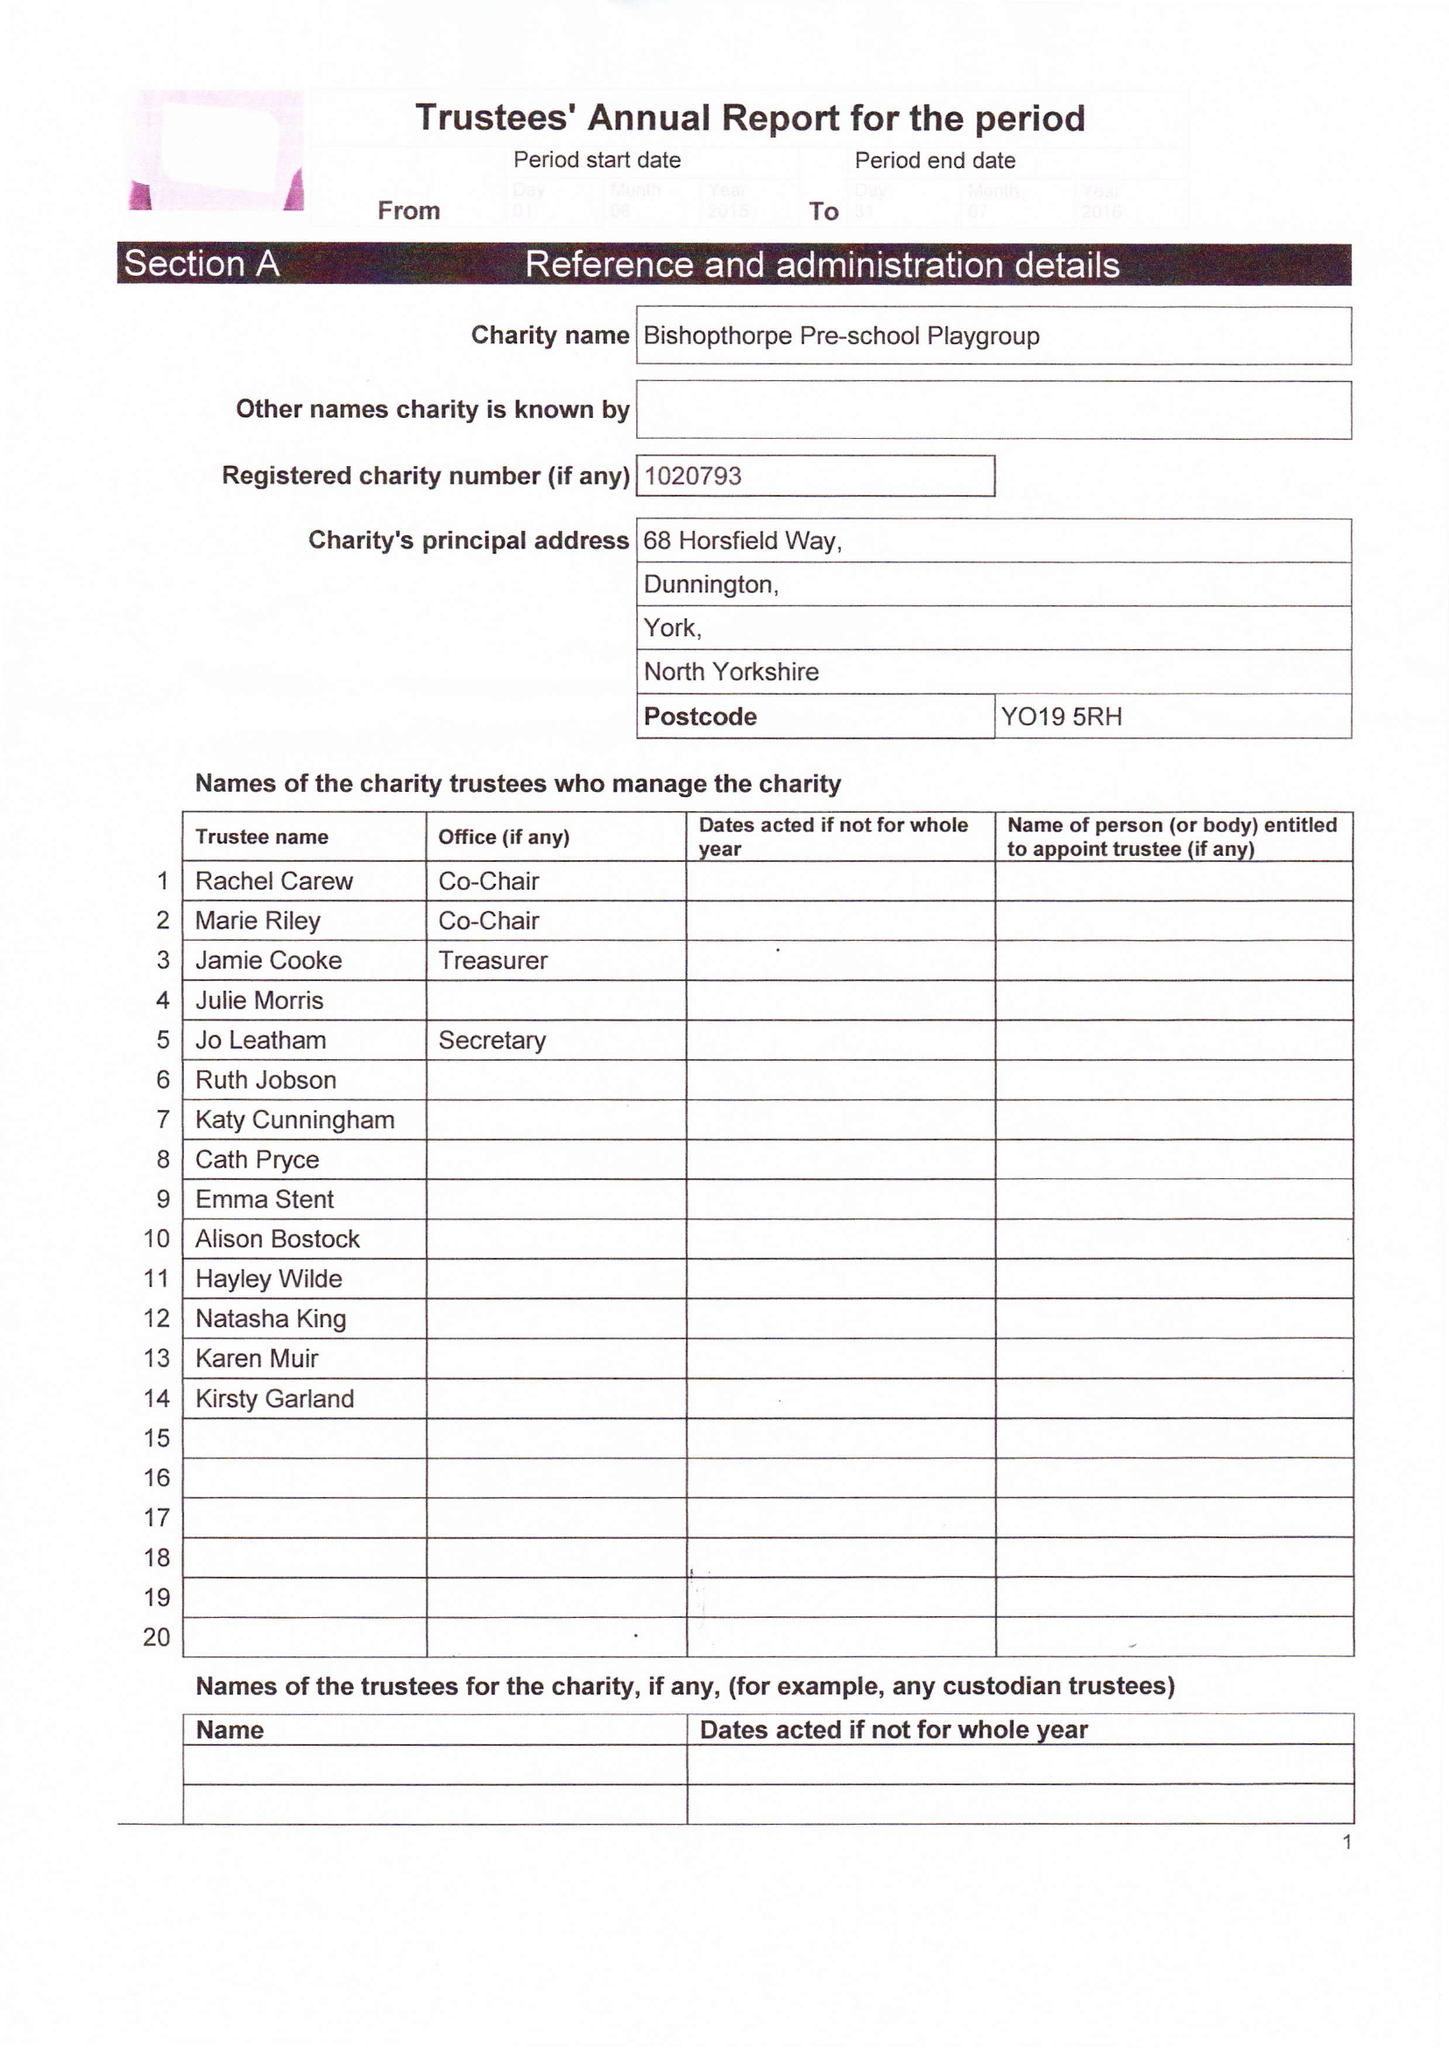What is the value for the address__street_line?
Answer the question using a single word or phrase. 68 HORSFIELD WAY 